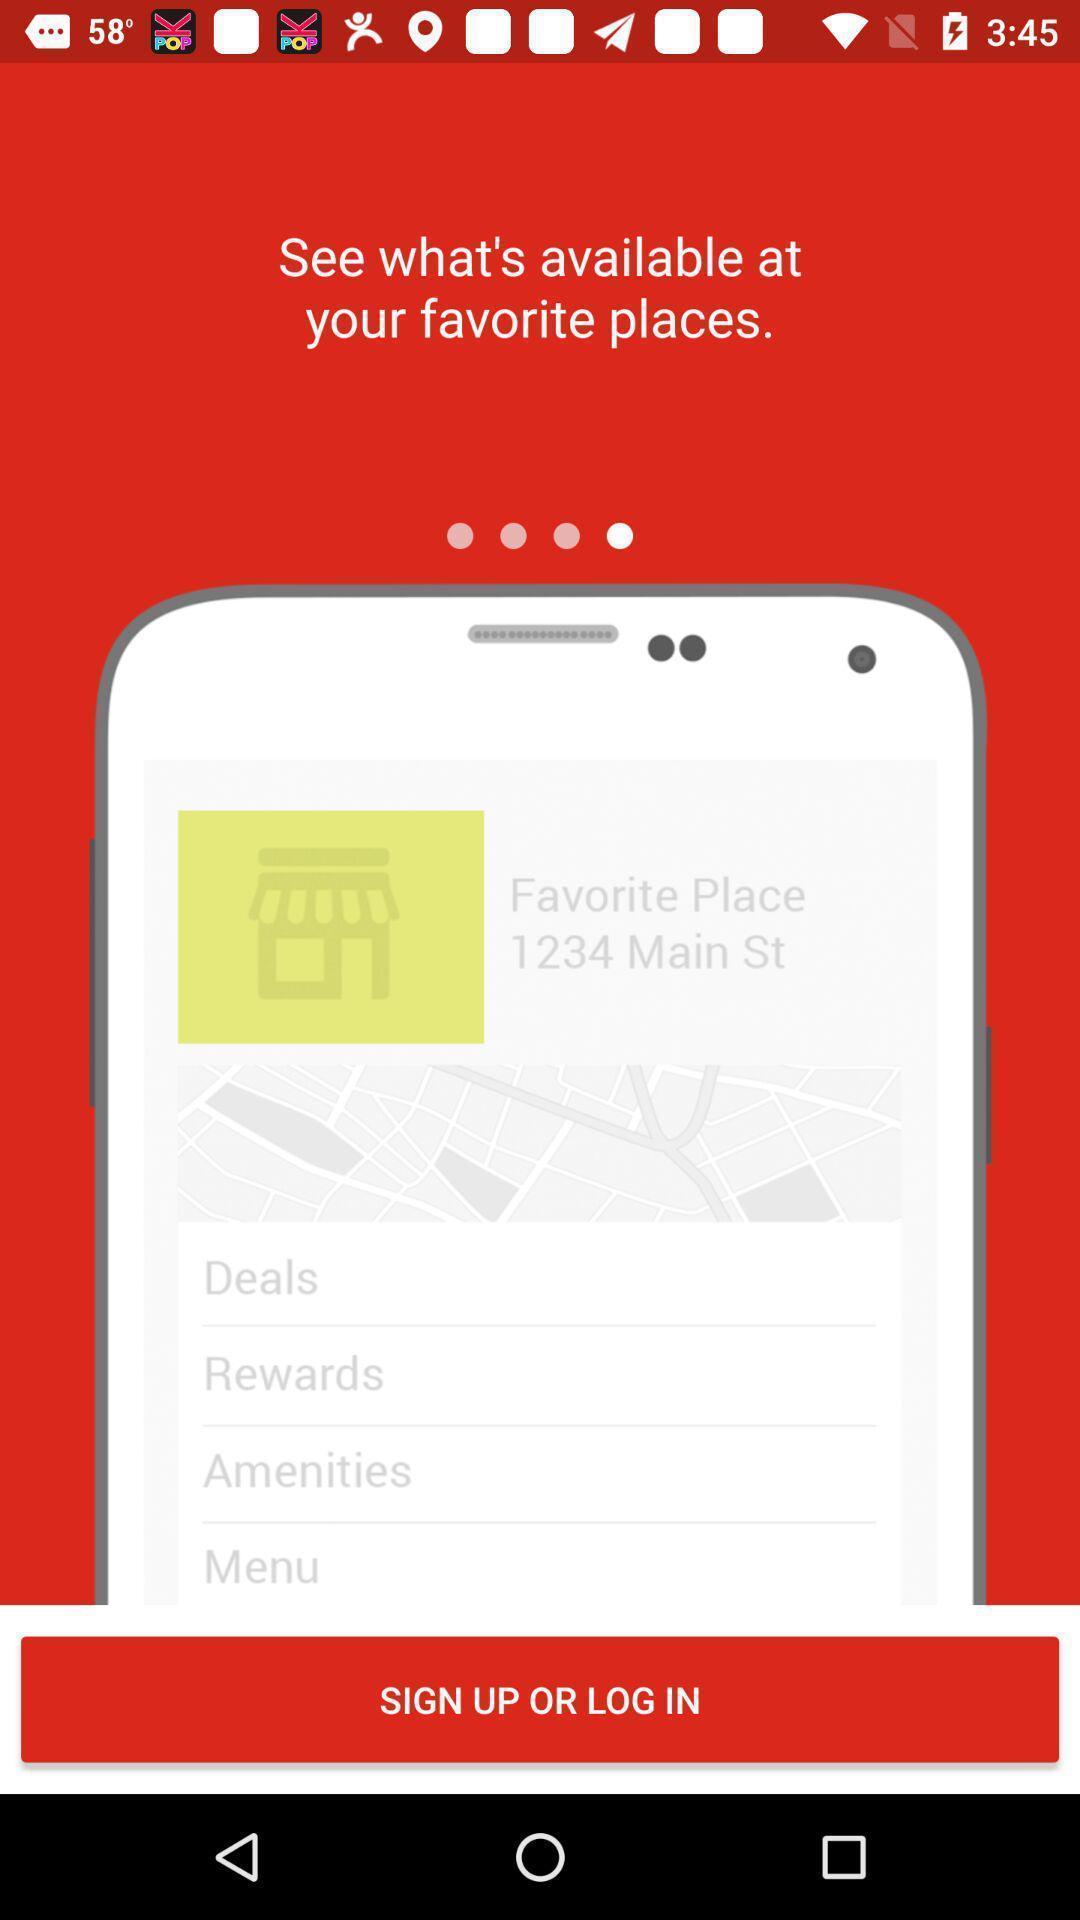Provide a description of this screenshot. Welcome page showing of login and sing up. 